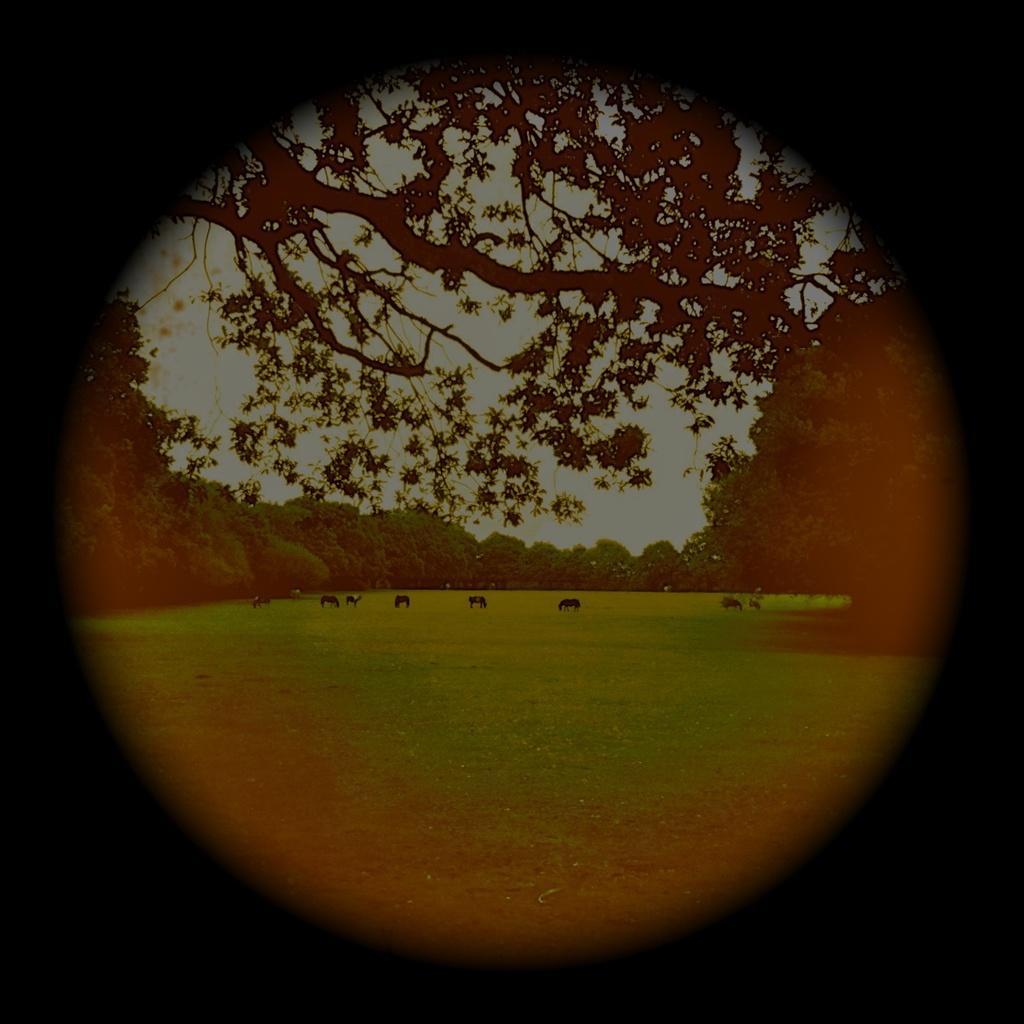Could you give a brief overview of what you see in this image? In this image I can see there are trees, in the middle there are animals. At the top it is the sky. 